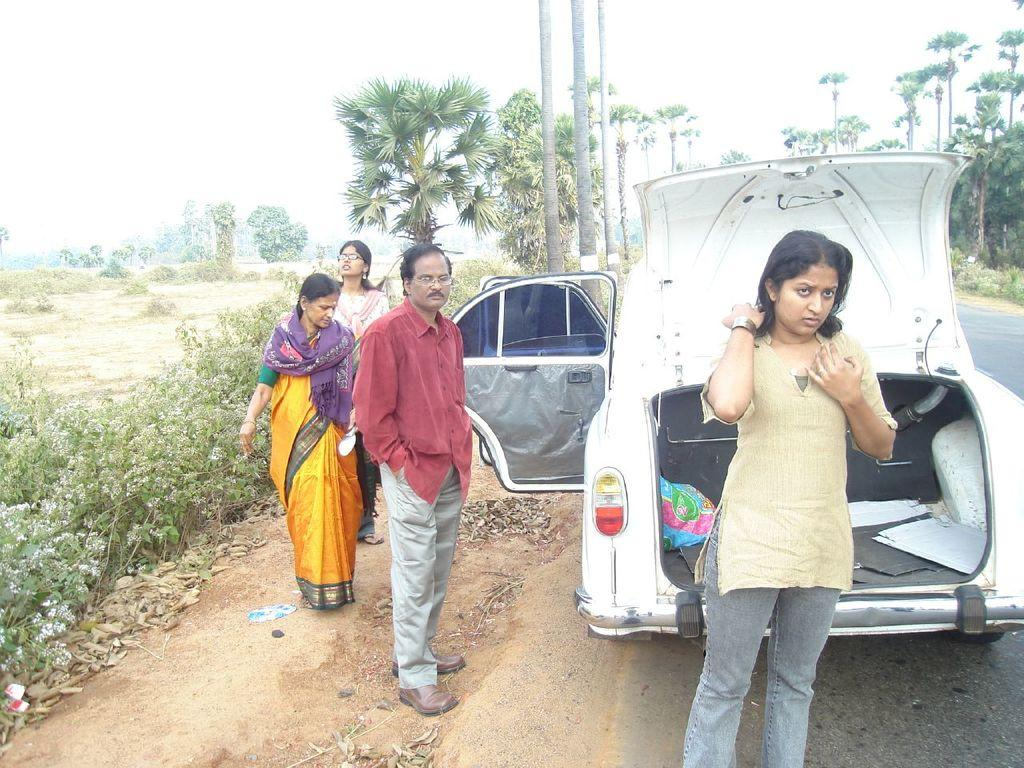How many people are standing on the road in the foreground? There are four persons standing on the road in the foreground. What else can be seen in the foreground besides the people? There is a car in the foreground. What type of vegetation is visible in the background? Trees are present in the background. What else can be seen in the background besides the trees? Grass and the sky are visible in the background. When was the image taken? The image was taken during the day. What type of crate is being used to shape the wheel in the image? There is no crate or wheel present in the image; it features four persons standing on the road and a car in the foreground. 